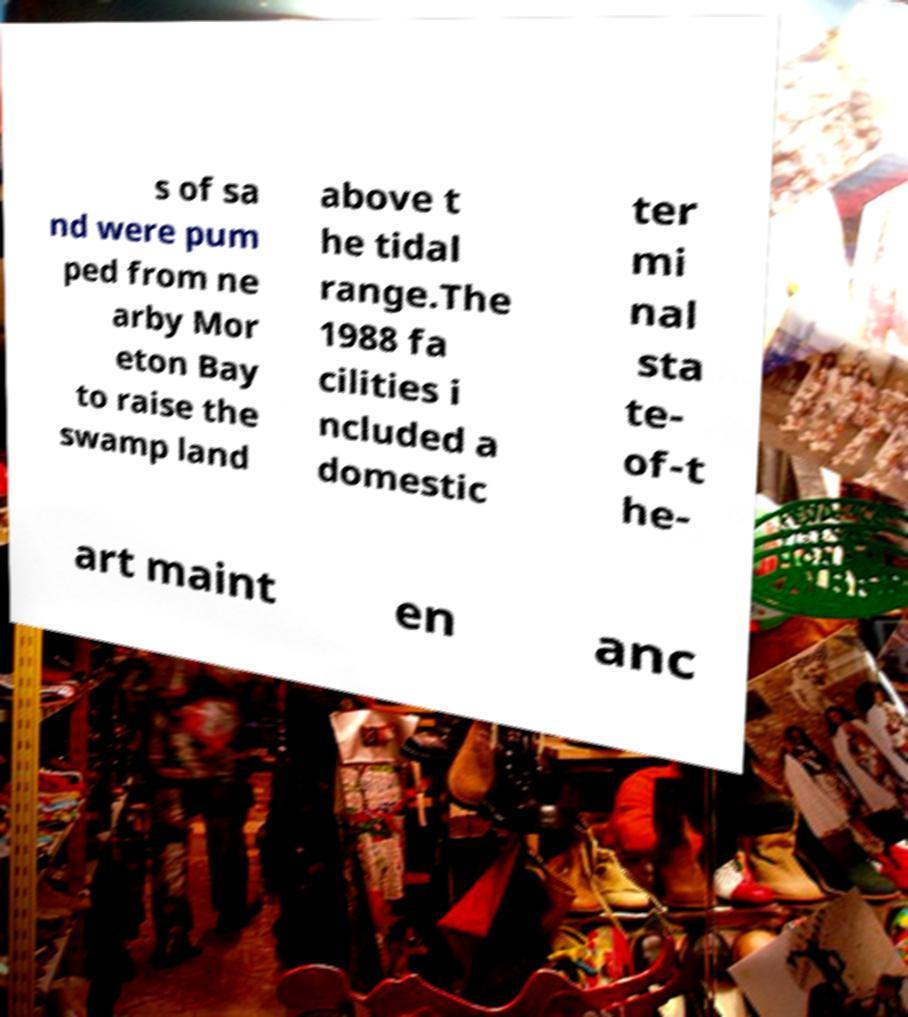Please identify and transcribe the text found in this image. s of sa nd were pum ped from ne arby Mor eton Bay to raise the swamp land above t he tidal range.The 1988 fa cilities i ncluded a domestic ter mi nal sta te- of-t he- art maint en anc 